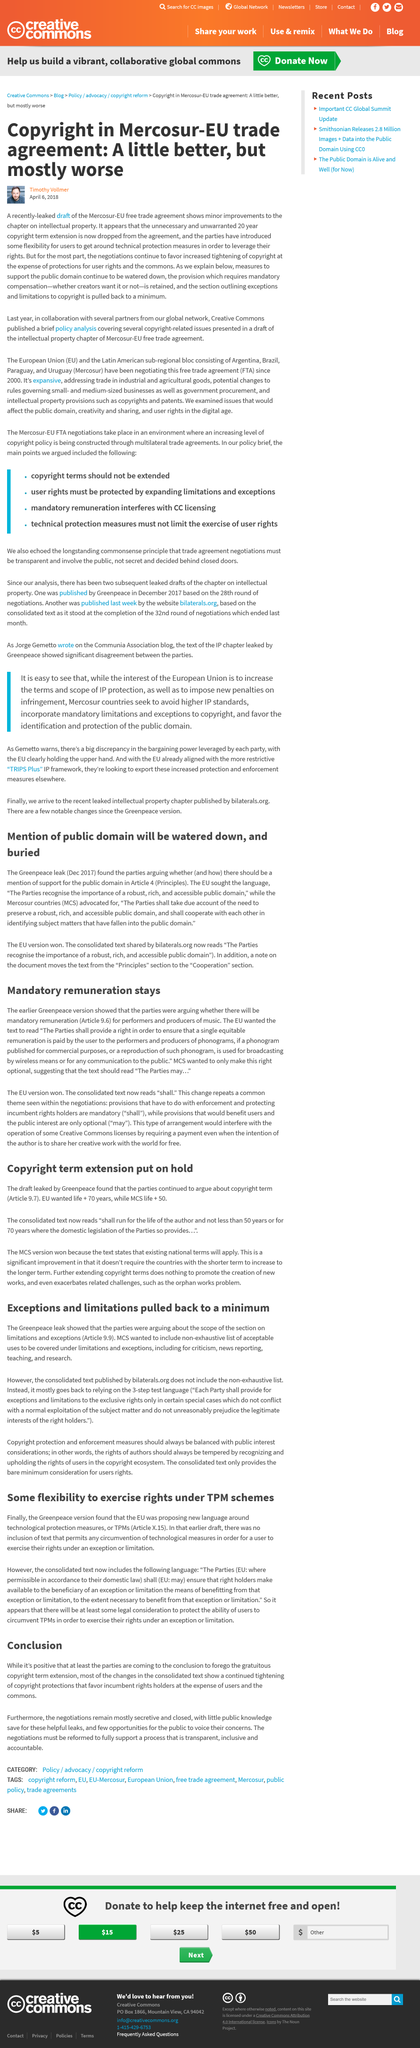Mention a couple of crucial points in this snapshot. The Greenpeace leak revealed that during the ongoing negotiations on the exception and limitations in Article 29, the parties are in disagreement regarding the scope of Section 29.1 on limitations and exceptions. The EU did not want the backstop to be optional. The Mercosur-EU free trade agreement is the trade agreement discussed in the article. The earlier draft failed to include any text that would permit circumvention of technological measures, thereby leaving out a crucial aspect that is required in order to comply with the law. The title of the article is 'Mandatory Remuneration Stays..' 